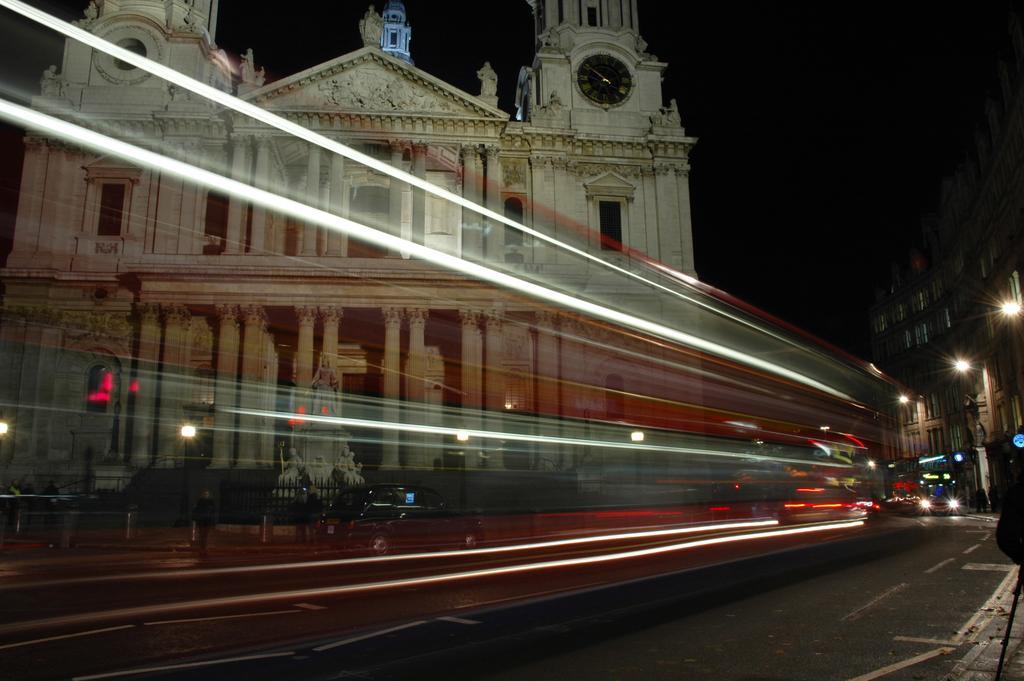Can you describe this image briefly? In this image we can see few buildings. There are few vehicles in the image. There are few street lights in the image. There is a statue in the image. We can see the dark sky in the image. There is a clock on the wall. 